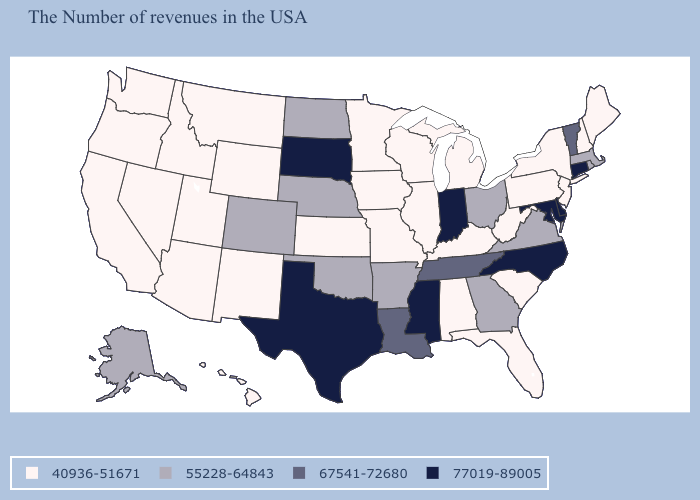Name the states that have a value in the range 40936-51671?
Answer briefly. Maine, New Hampshire, New York, New Jersey, Pennsylvania, South Carolina, West Virginia, Florida, Michigan, Kentucky, Alabama, Wisconsin, Illinois, Missouri, Minnesota, Iowa, Kansas, Wyoming, New Mexico, Utah, Montana, Arizona, Idaho, Nevada, California, Washington, Oregon, Hawaii. What is the value of Louisiana?
Keep it brief. 67541-72680. Is the legend a continuous bar?
Answer briefly. No. What is the value of Utah?
Be succinct. 40936-51671. What is the lowest value in the USA?
Keep it brief. 40936-51671. Does Missouri have the lowest value in the USA?
Answer briefly. Yes. Name the states that have a value in the range 40936-51671?
Concise answer only. Maine, New Hampshire, New York, New Jersey, Pennsylvania, South Carolina, West Virginia, Florida, Michigan, Kentucky, Alabama, Wisconsin, Illinois, Missouri, Minnesota, Iowa, Kansas, Wyoming, New Mexico, Utah, Montana, Arizona, Idaho, Nevada, California, Washington, Oregon, Hawaii. Among the states that border New York , does New Jersey have the lowest value?
Short answer required. Yes. What is the value of Utah?
Keep it brief. 40936-51671. Name the states that have a value in the range 77019-89005?
Short answer required. Connecticut, Delaware, Maryland, North Carolina, Indiana, Mississippi, Texas, South Dakota. What is the value of South Carolina?
Quick response, please. 40936-51671. Name the states that have a value in the range 77019-89005?
Quick response, please. Connecticut, Delaware, Maryland, North Carolina, Indiana, Mississippi, Texas, South Dakota. What is the value of New Jersey?
Be succinct. 40936-51671. What is the highest value in the USA?
Quick response, please. 77019-89005. Which states have the highest value in the USA?
Concise answer only. Connecticut, Delaware, Maryland, North Carolina, Indiana, Mississippi, Texas, South Dakota. 